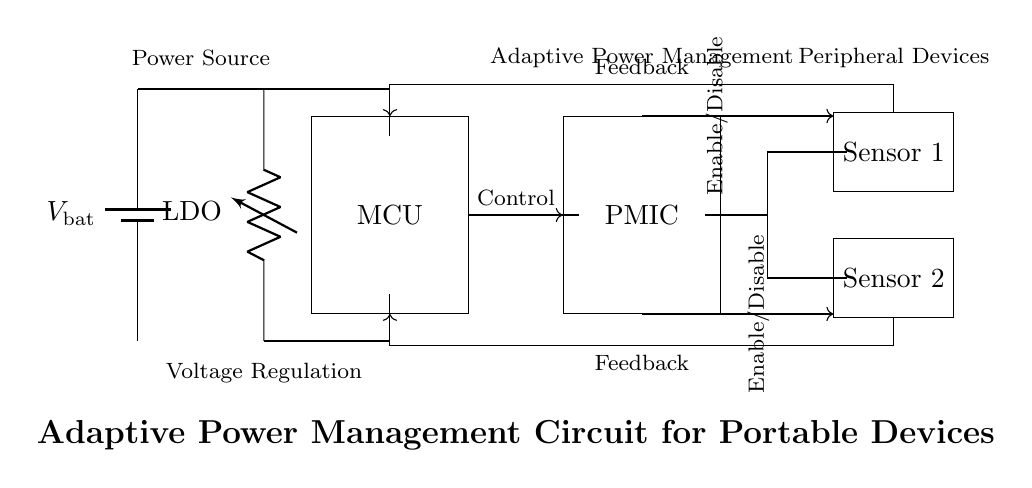What is the main power source in this circuit? The main power source is represented by the battery, labeled as V_bat. The diagram clearly shows a battery symbol, indicating it is the source of power for the circuit.
Answer: Battery What does LDO stand for in this circuit diagram? LDO stands for Low Drop-Out regulator. It is indicated next to the voltage regulator component, which shows that it is designed to provide a stable output voltage while maintaining a low voltage drop.
Answer: Low Drop-Out How many sensors are present in the circuit? The circuit diagram contains two sensors, labeled Sensor 1 and Sensor 2, which are depicted as separate components on the right side of the diagram.
Answer: Two What is the role of the PMIC in the circuit? PMIC stands for Power Management Integrated Circuit. It is shown in the diagram to manage the distribution and regulation of power to other components, specifically the microcontroller and sensors, thereby optimizing battery life.
Answer: Power Management What type of feedback mechanism is employed in this circuit? The circuit implements a feedback mechanism from the microcontroller to both sensors. This is illustrated in the diagram by arrows indicating the feedback direction, signifying that the MCU receives information from the sensors to make adjustments.
Answer: Feedback What is the relationship between the microcontroller and the PMIC? The microcontroller sends control signals to the PMIC, indicated by an arrow connecting the two components, suggesting the microcontroller controls the operation of the PMIC based on input from the sensors.
Answer: Control signals What would happen if the sensors are disabled? If the sensors are disabled, the adaptive power management might not function optimally, potentially leading to unnecessary power consumption since the feedback loops would be interrupted, preventing the microcontroller from receiving status updates from the sensors.
Answer: Inefficient power management 